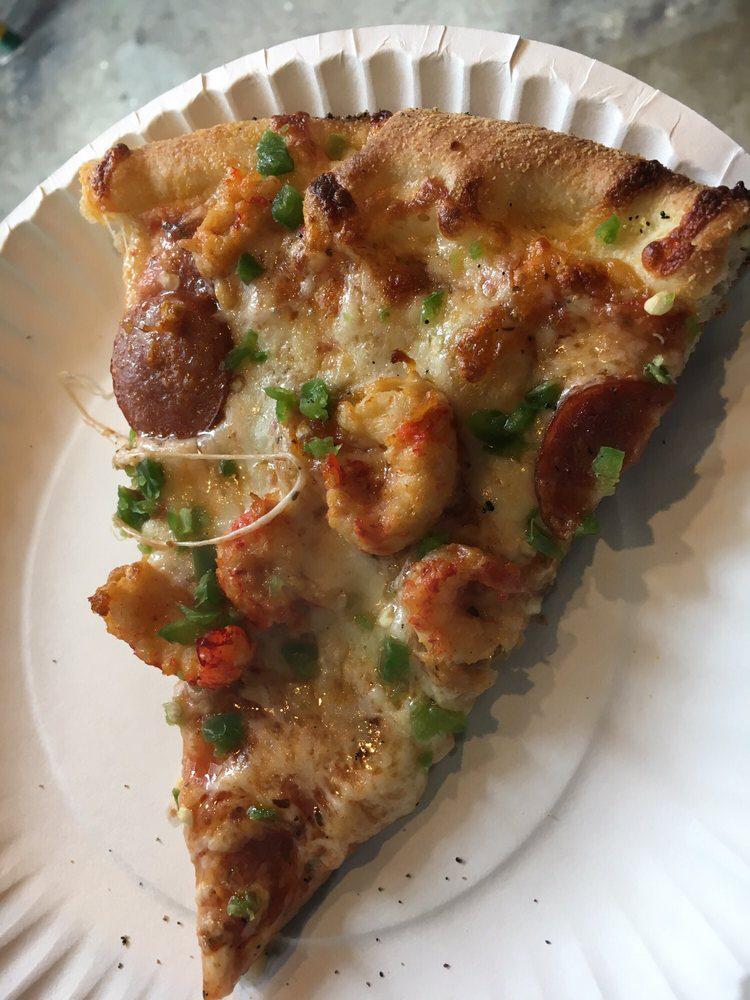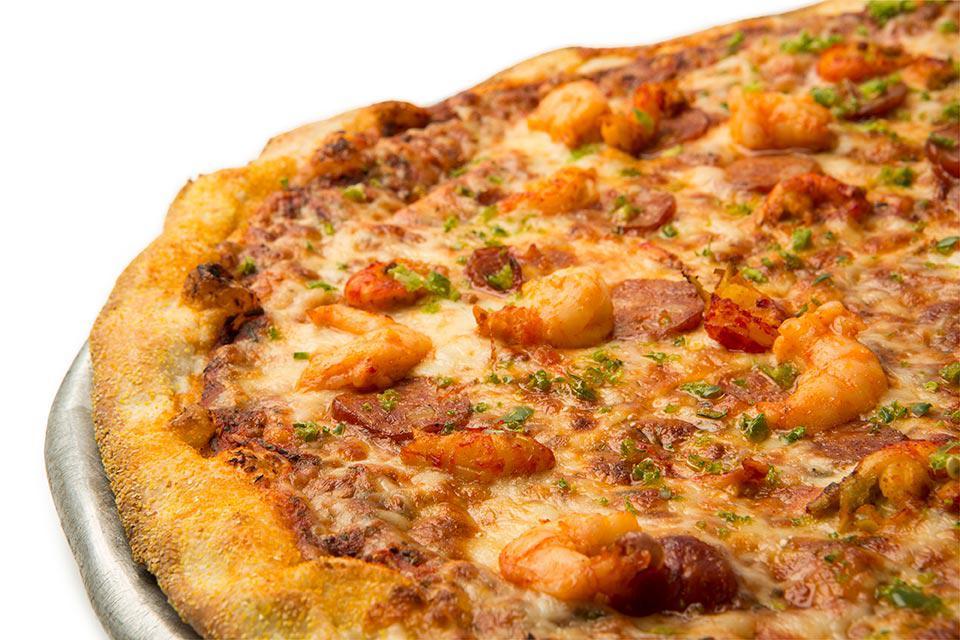The first image is the image on the left, the second image is the image on the right. Evaluate the accuracy of this statement regarding the images: "One image shows an unsliced pizza, and the other image features less than an entire pizza but at least one slice.". Is it true? Answer yes or no. Yes. The first image is the image on the left, the second image is the image on the right. For the images shown, is this caption "The left and right image contains the same number of full pizzas." true? Answer yes or no. No. 